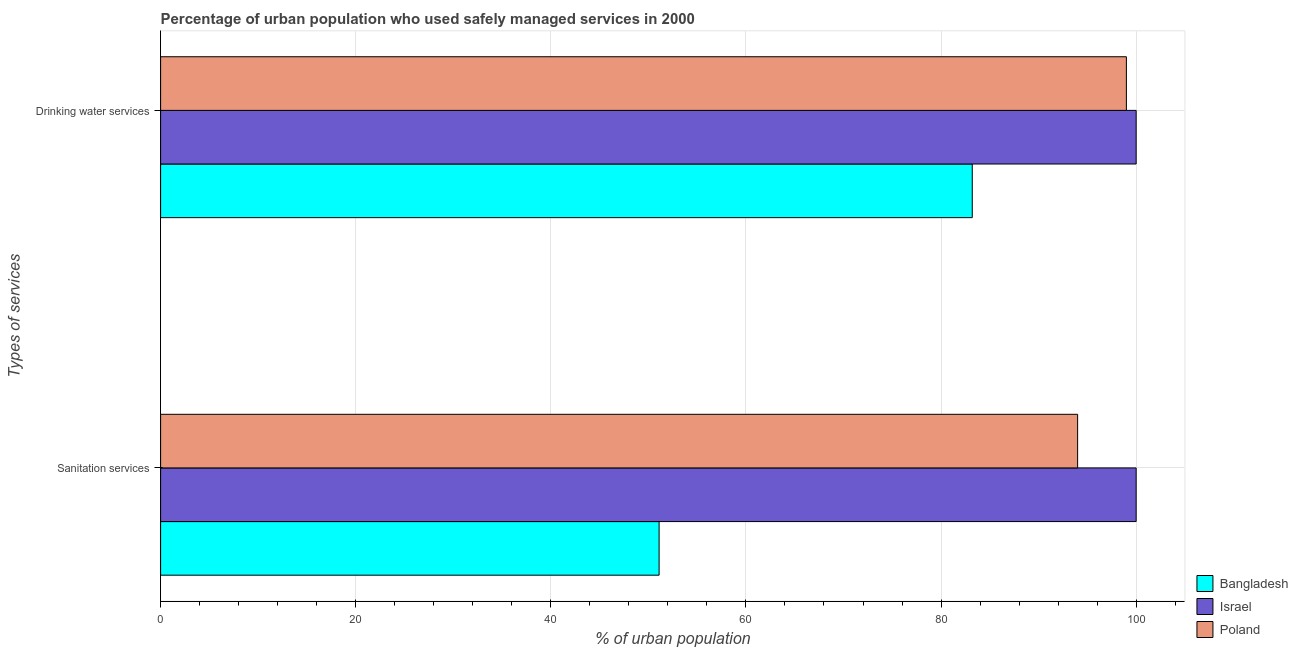What is the label of the 2nd group of bars from the top?
Offer a very short reply. Sanitation services. What is the percentage of urban population who used drinking water services in Israel?
Provide a succinct answer. 100. Across all countries, what is the minimum percentage of urban population who used sanitation services?
Make the answer very short. 51.1. What is the total percentage of urban population who used sanitation services in the graph?
Your response must be concise. 245.1. What is the difference between the percentage of urban population who used drinking water services in Poland and that in Bangladesh?
Your answer should be compact. 15.8. What is the difference between the percentage of urban population who used drinking water services in Israel and the percentage of urban population who used sanitation services in Bangladesh?
Offer a very short reply. 48.9. What is the average percentage of urban population who used sanitation services per country?
Provide a short and direct response. 81.7. What is the difference between the percentage of urban population who used drinking water services and percentage of urban population who used sanitation services in Israel?
Provide a short and direct response. 0. How many bars are there?
Give a very brief answer. 6. Are all the bars in the graph horizontal?
Provide a succinct answer. Yes. What is the difference between two consecutive major ticks on the X-axis?
Provide a short and direct response. 20. Does the graph contain any zero values?
Offer a very short reply. No. Where does the legend appear in the graph?
Your answer should be compact. Bottom right. How are the legend labels stacked?
Offer a very short reply. Vertical. What is the title of the graph?
Provide a short and direct response. Percentage of urban population who used safely managed services in 2000. What is the label or title of the X-axis?
Keep it short and to the point. % of urban population. What is the label or title of the Y-axis?
Offer a terse response. Types of services. What is the % of urban population in Bangladesh in Sanitation services?
Your response must be concise. 51.1. What is the % of urban population of Poland in Sanitation services?
Your response must be concise. 94. What is the % of urban population in Bangladesh in Drinking water services?
Offer a terse response. 83.2. What is the % of urban population in Israel in Drinking water services?
Your answer should be very brief. 100. What is the % of urban population in Poland in Drinking water services?
Offer a very short reply. 99. Across all Types of services, what is the maximum % of urban population of Bangladesh?
Offer a terse response. 83.2. Across all Types of services, what is the maximum % of urban population of Israel?
Offer a terse response. 100. Across all Types of services, what is the minimum % of urban population of Bangladesh?
Provide a short and direct response. 51.1. Across all Types of services, what is the minimum % of urban population in Israel?
Provide a short and direct response. 100. Across all Types of services, what is the minimum % of urban population in Poland?
Make the answer very short. 94. What is the total % of urban population of Bangladesh in the graph?
Make the answer very short. 134.3. What is the total % of urban population of Israel in the graph?
Keep it short and to the point. 200. What is the total % of urban population of Poland in the graph?
Provide a succinct answer. 193. What is the difference between the % of urban population of Bangladesh in Sanitation services and that in Drinking water services?
Keep it short and to the point. -32.1. What is the difference between the % of urban population of Israel in Sanitation services and that in Drinking water services?
Make the answer very short. 0. What is the difference between the % of urban population of Bangladesh in Sanitation services and the % of urban population of Israel in Drinking water services?
Your answer should be compact. -48.9. What is the difference between the % of urban population of Bangladesh in Sanitation services and the % of urban population of Poland in Drinking water services?
Keep it short and to the point. -47.9. What is the average % of urban population of Bangladesh per Types of services?
Offer a very short reply. 67.15. What is the average % of urban population of Poland per Types of services?
Provide a succinct answer. 96.5. What is the difference between the % of urban population of Bangladesh and % of urban population of Israel in Sanitation services?
Your response must be concise. -48.9. What is the difference between the % of urban population in Bangladesh and % of urban population in Poland in Sanitation services?
Provide a short and direct response. -42.9. What is the difference between the % of urban population of Israel and % of urban population of Poland in Sanitation services?
Ensure brevity in your answer.  6. What is the difference between the % of urban population in Bangladesh and % of urban population in Israel in Drinking water services?
Your answer should be compact. -16.8. What is the difference between the % of urban population in Bangladesh and % of urban population in Poland in Drinking water services?
Offer a terse response. -15.8. What is the difference between the % of urban population of Israel and % of urban population of Poland in Drinking water services?
Your answer should be compact. 1. What is the ratio of the % of urban population in Bangladesh in Sanitation services to that in Drinking water services?
Give a very brief answer. 0.61. What is the ratio of the % of urban population of Poland in Sanitation services to that in Drinking water services?
Offer a terse response. 0.95. What is the difference between the highest and the second highest % of urban population in Bangladesh?
Provide a succinct answer. 32.1. What is the difference between the highest and the second highest % of urban population of Poland?
Offer a terse response. 5. What is the difference between the highest and the lowest % of urban population of Bangladesh?
Your answer should be compact. 32.1. What is the difference between the highest and the lowest % of urban population of Poland?
Offer a terse response. 5. 